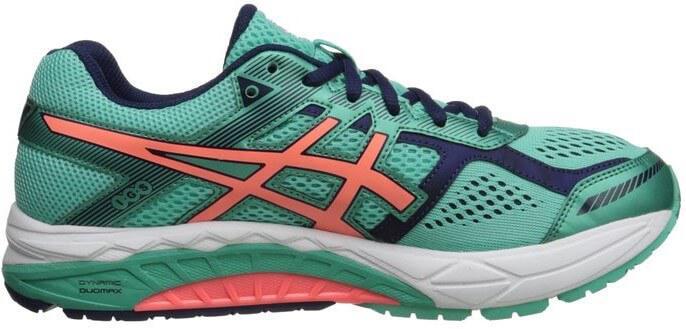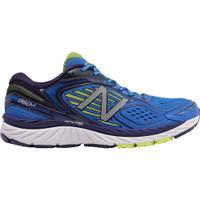The first image is the image on the left, the second image is the image on the right. Evaluate the accuracy of this statement regarding the images: "All shoes pictured are facing rightward.". Is it true? Answer yes or no. Yes. The first image is the image on the left, the second image is the image on the right. For the images shown, is this caption "There is at least one sneaker that is mainly gray and has blue laces." true? Answer yes or no. No. 